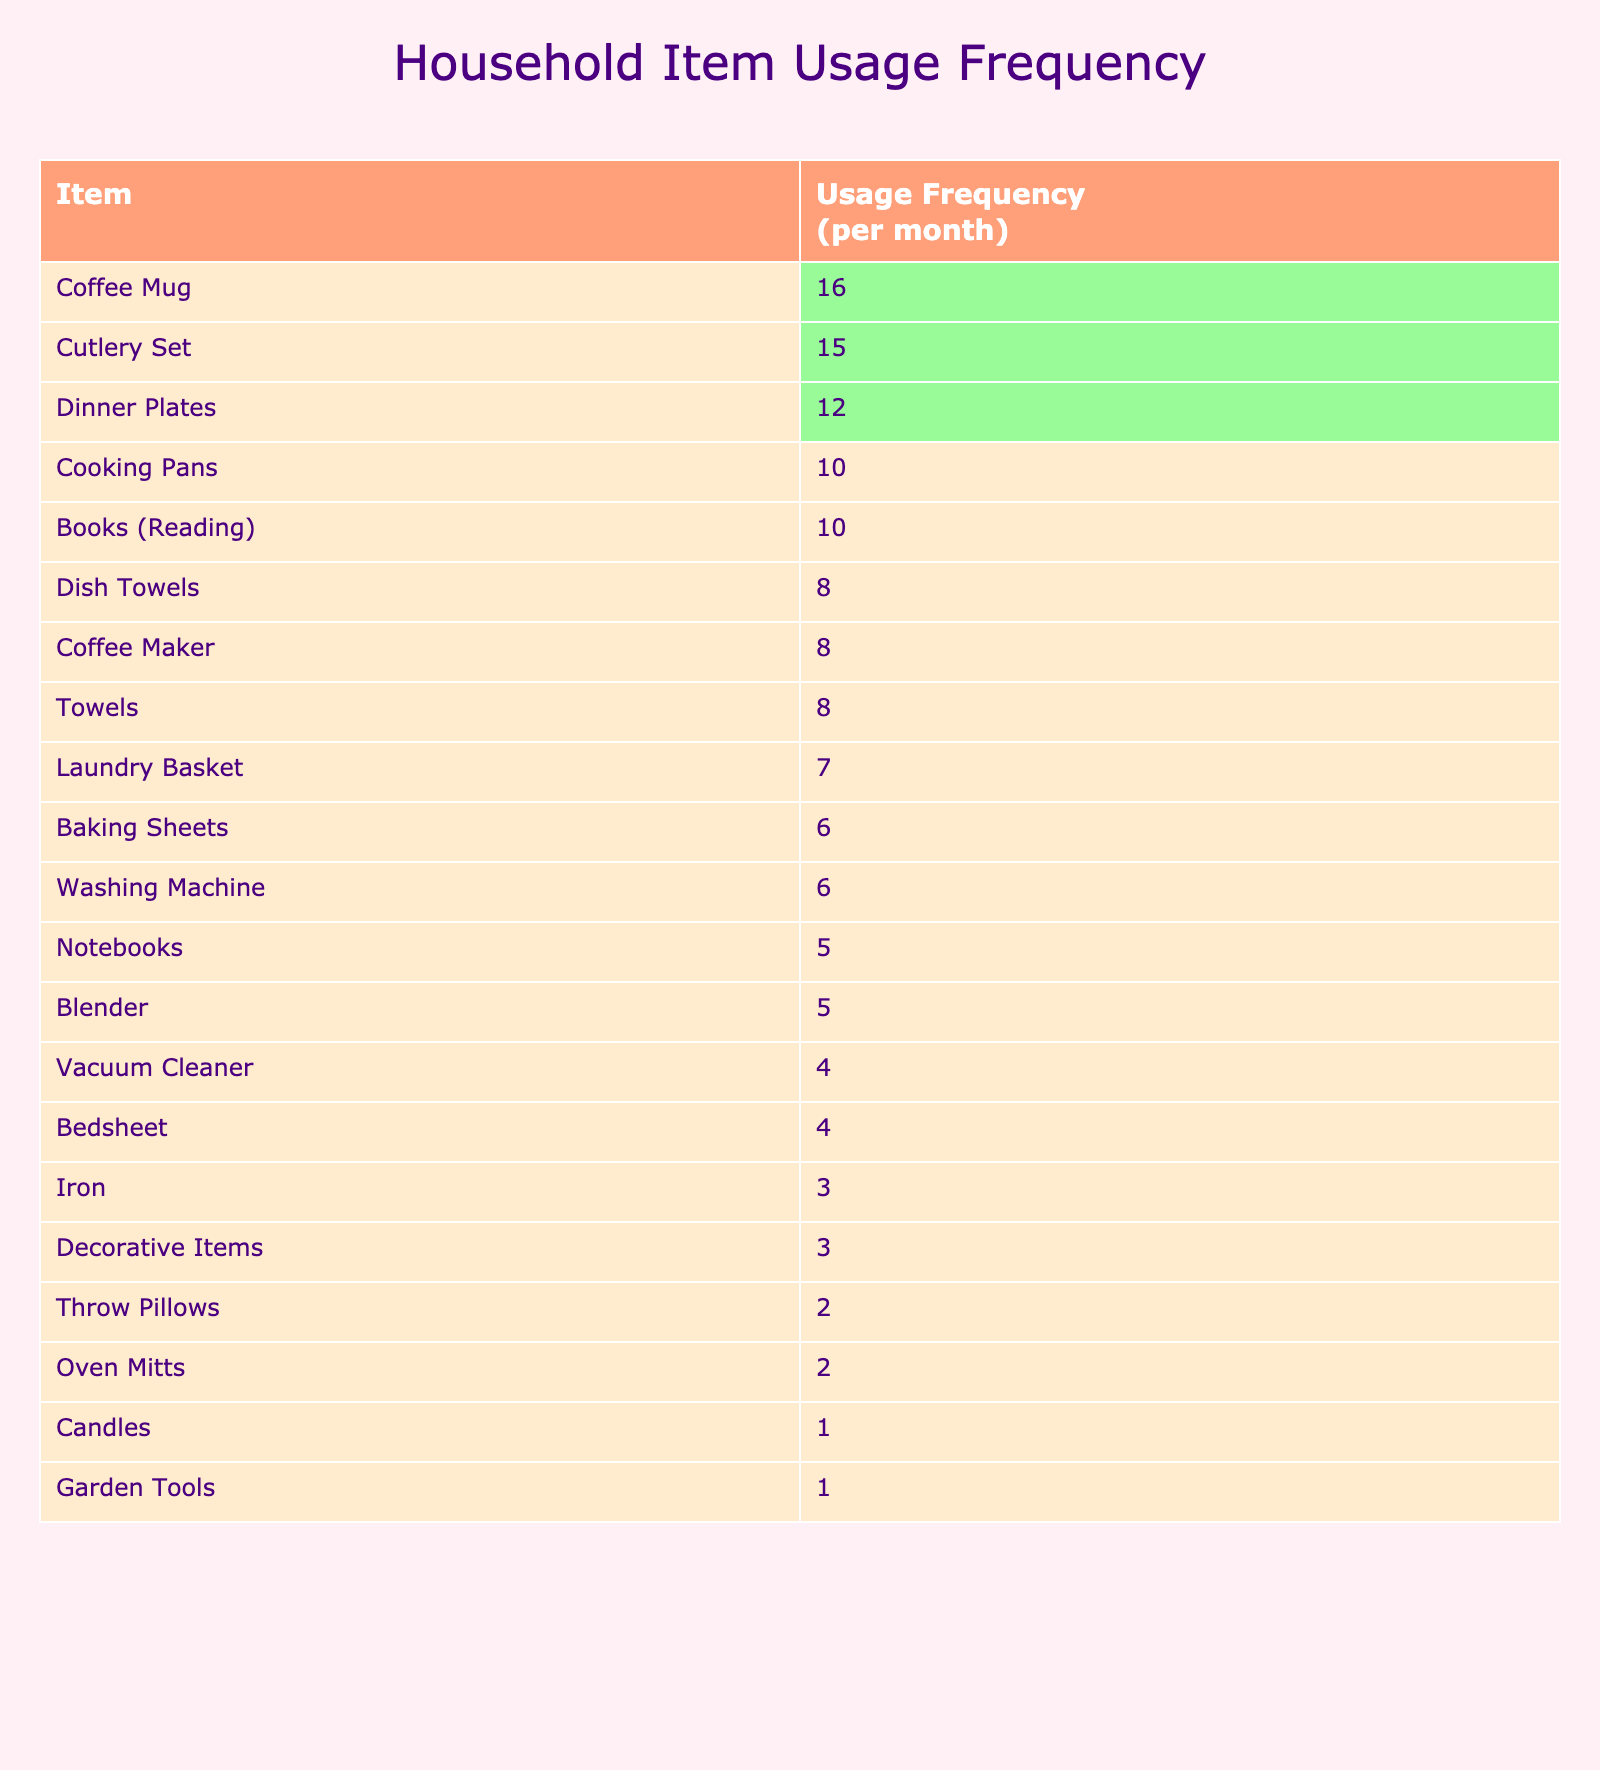What is the most frequently used household item? The item with the highest usage frequency in the table is "Coffee Mug" with a frequency of 16.
Answer: Coffee Mug How many times are cooking pans used in comparison to oven mitts? Cooking pans are used 10 times a month, while oven mitts are used 2 times. The difference is 10 - 2 = 8.
Answer: 8 Is the usage frequency of dish towels greater than that of towels? Dish towels are used 8 times a month, while towels are used 8 times as well. Therefore, they are equal, not greater.
Answer: No What is the total usage frequency of the top three most used items? The top three items are "Coffee Mug" (16), "Cutlery Set" (15), and "Dinner Plates" (12). Their total frequency is 16 + 15 + 12 = 43.
Answer: 43 What is the average usage frequency of all household items listed? There are 20 items in total, and summing their frequencies gives 70. The average is 70 / 20 = 3.5.
Answer: 3.5 Which items are used more than 10 times a month? The items "Coffee Mug", "Cutlery Set", and "Dinner Plates" are used more than 10 times a month.
Answer: Coffee Mug, Cutlery Set, Dinner Plates What is the difference in usage frequency between the least and most frequently used items? The least used item is "Candles" (1), and the most used item is "Coffee Mug" (16). The difference is 16 - 1 = 15.
Answer: 15 How many items have a usage frequency of 5 or less? The items "Oven Mitts" (2), "Candles" (1), "Throw Pillows" (2), and "Iron" (3), and "Notebooks" (5) sum up to 5 items in total.
Answer: 5 How many household items are used 8 times a month? The items used 8 times a month are "Towels", "Dish Towels", and "Coffee Maker". There are 3 items in total.
Answer: 3 What is the combined usage frequency of garden tools, decorative items, and throw pillows? The frequencies for garden tools (1), decorative items (3), and throw pillows (2) combine to 1 + 3 + 2 = 6.
Answer: 6 